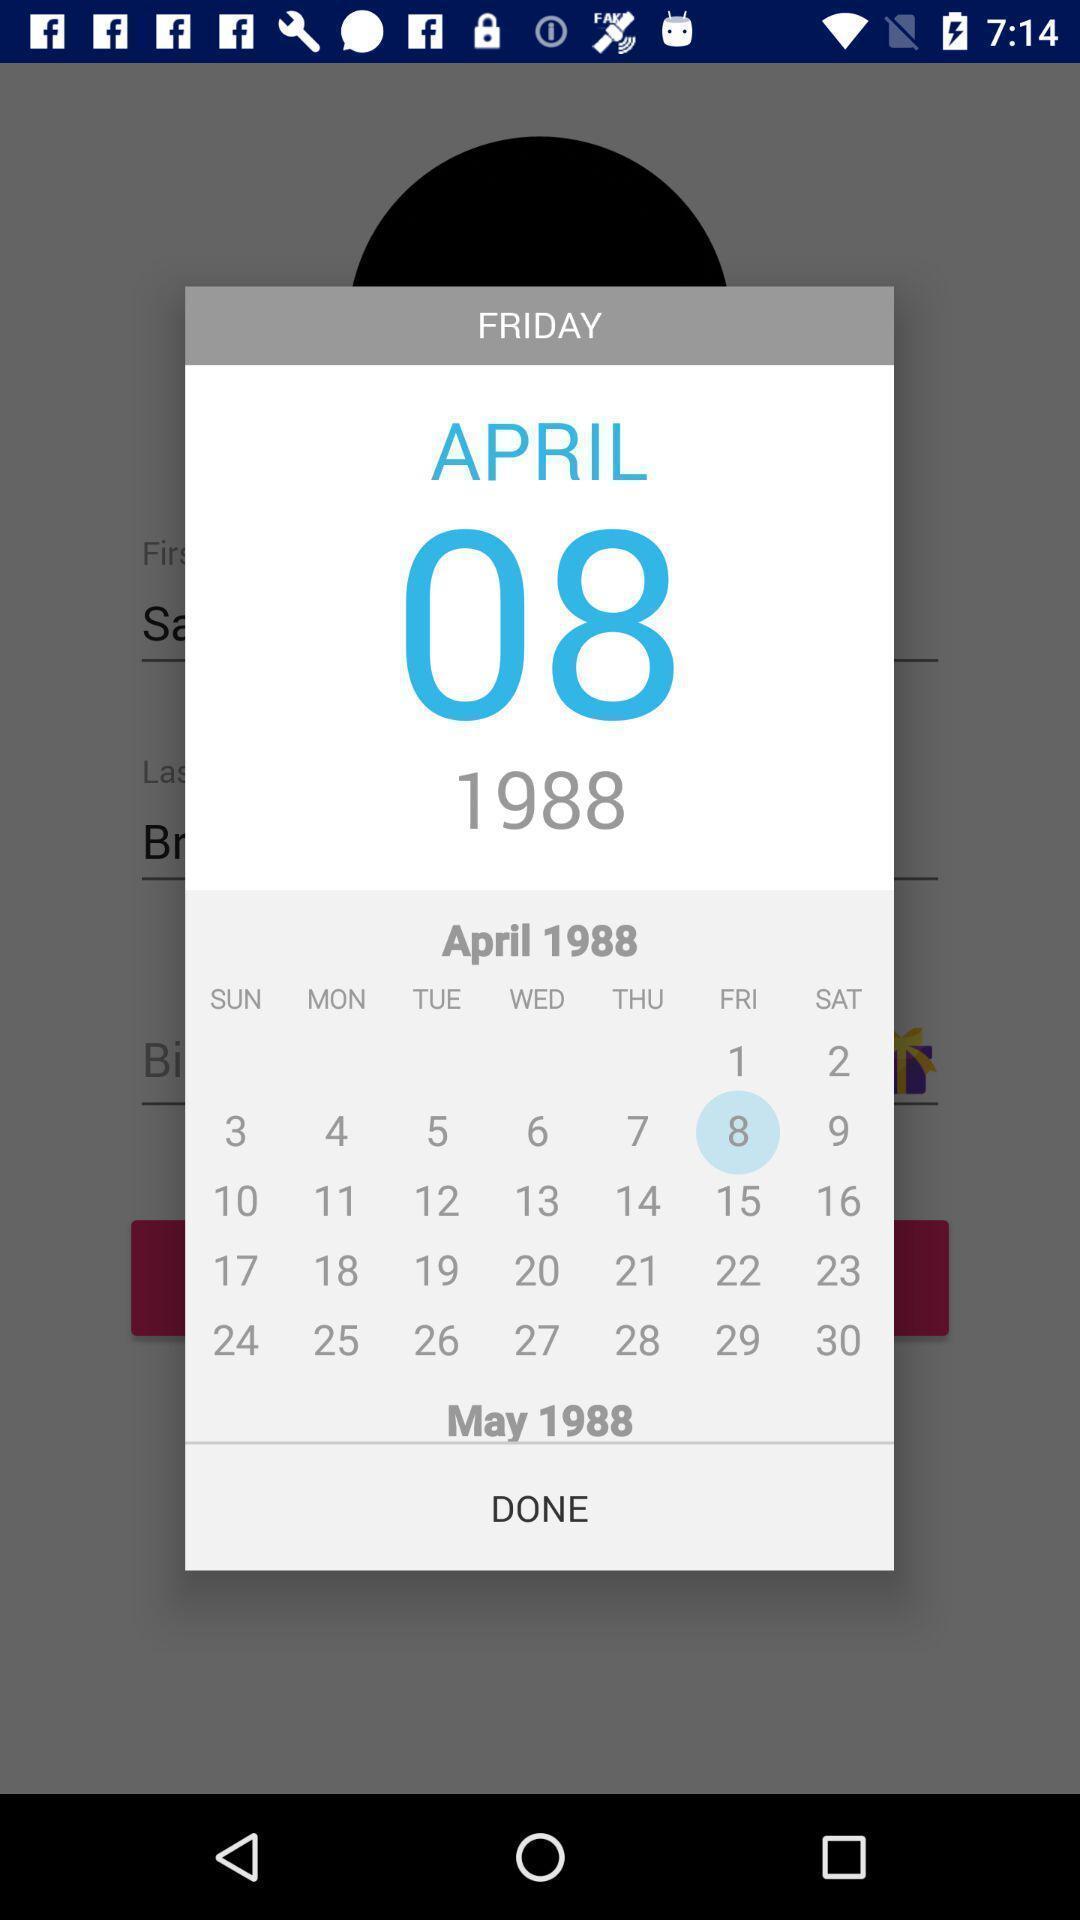Provide a textual representation of this image. Pop up showing a specific date in calendar. 